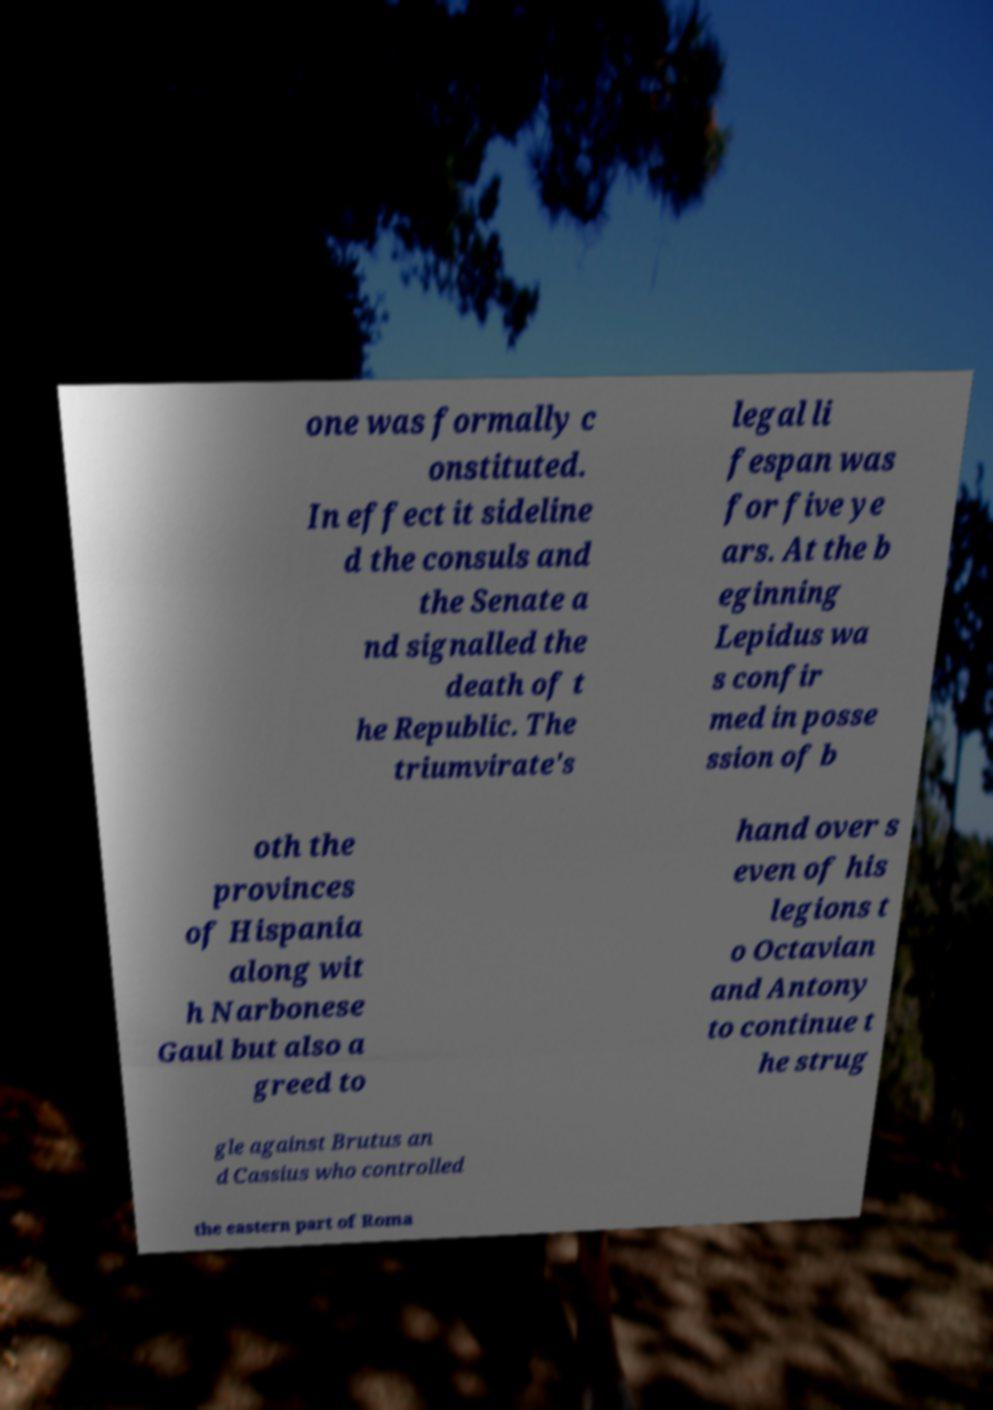For documentation purposes, I need the text within this image transcribed. Could you provide that? one was formally c onstituted. In effect it sideline d the consuls and the Senate a nd signalled the death of t he Republic. The triumvirate's legal li fespan was for five ye ars. At the b eginning Lepidus wa s confir med in posse ssion of b oth the provinces of Hispania along wit h Narbonese Gaul but also a greed to hand over s even of his legions t o Octavian and Antony to continue t he strug gle against Brutus an d Cassius who controlled the eastern part of Roma 